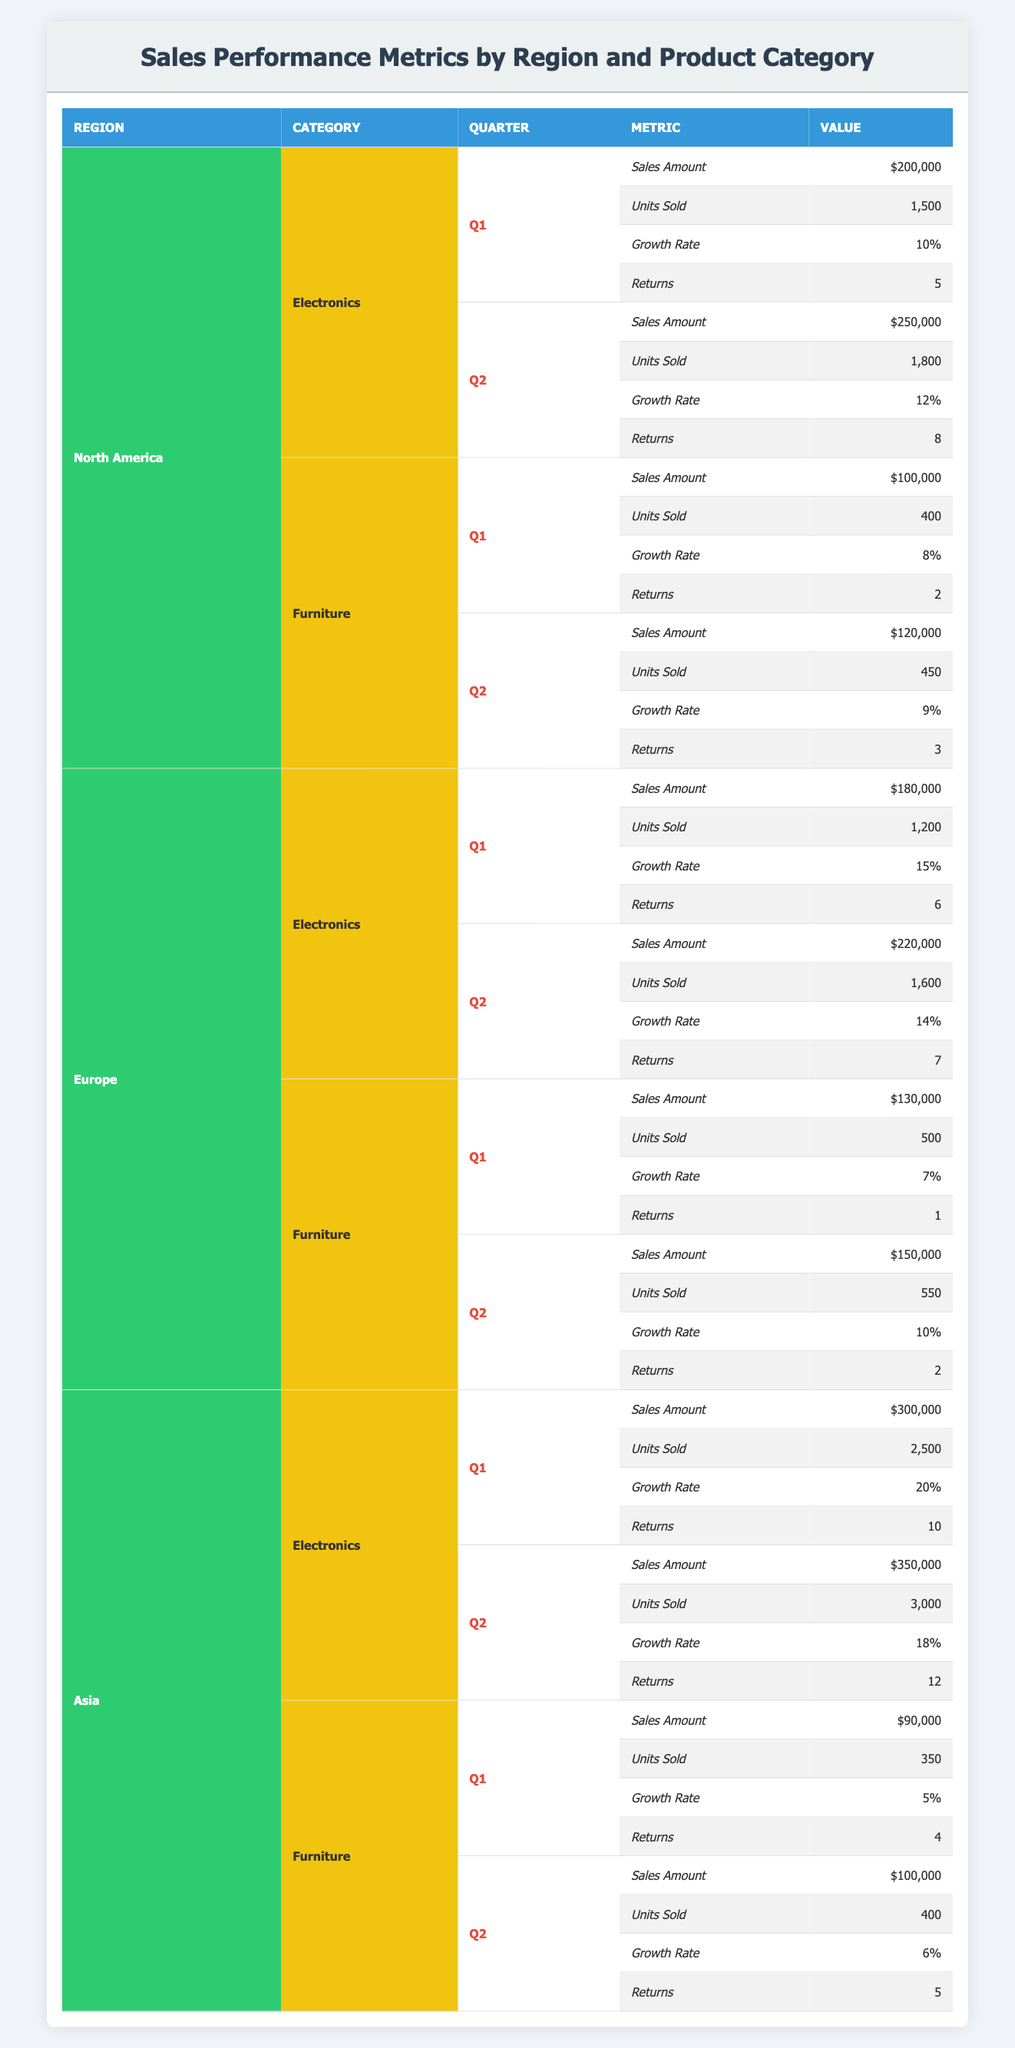What is the total sales amount for Electronics in North America across both quarters? To find the total sales amount for Electronics in North America, we need to add the sales amounts for Q1 and Q2. Q1 sales amount is $200,000 and Q2 sales amount is $250,000. Therefore, $200,000 + $250,000 equals $450,000.
Answer: $450,000 How many units of Furniture were sold in Q2 across all regions? We need to sum the units sold for Furniture in Q2 across North America, Europe, and Asia. In North America, 450 units were sold. In Europe, 550 units were sold. In Asia, 400 units were sold. Adding these values gives us 450 + 550 + 400, which equals 1,400 units.
Answer: 1,400 Was there an increase in the growth rate for Electronics from Q1 to Q2 in Asia? To answer this, we look at the growth rates in Asia for Electronics in Q1 and Q2. In Q1, the growth rate was 20%, and in Q2, it decreased to 18%. Since 18% is less than 20%, the answer is no; there was not an increase.
Answer: No What is the total number of returns for Furniture in Europe across both quarters? We will sum the returns for Furniture in Europe for Q1 and Q2. In Q1, there was 1 return, and in Q2, there were 2 returns. Therefore, the total returns are 1 + 2 equals 3.
Answer: 3 Which product category in North America had the highest sales amount in Q1? We need to compare the sales amounts for both product categories in North America for Q1. Electronics had a sales amount of $200,000, and Furniture had a sales amount of $100,000. Since $200,000 is greater than $100,000, the highest sales amount was in Electronics.
Answer: Electronics What was the average growth rate for Furniture in North America across both quarters? We look at the growth rates for Furniture in North America: Q1 was 8% and Q2 was 9%. To find the average, we add the two rates (8 + 9) and divide by 2: (17 / 2 = 8.5).
Answer: 8.5% How did the Electronics sales amounts in Europe compare to those in Asia for Q1? We need to compare the sales amounts for Q1: Europe’s Electronics sales amount was $180,000, and Asia’s was $300,000. Since $180,000 is less than $300,000, the sales amount in Europe is lower than in Asia for Q1.
Answer: Europe had lower sales What is the difference in units sold for Electronics between Asia and North America in Q2? In North America, Electronics units sold in Q2 were 1,800, and in Asia, they were 3,000. To find the difference, we subtract North America’s figures from Asia’s: 3,000 - 1,800 equals 1,200 units.
Answer: 1,200 Was the sales amount for Furniture in Europe higher in Q2 compared to Q1? In Europe, the sales amount for Furniture in Q1 was $130,000 and in Q2 it was $150,000. Since $150,000 is greater than $130,000, the answer is yes; it was higher in Q2.
Answer: Yes 